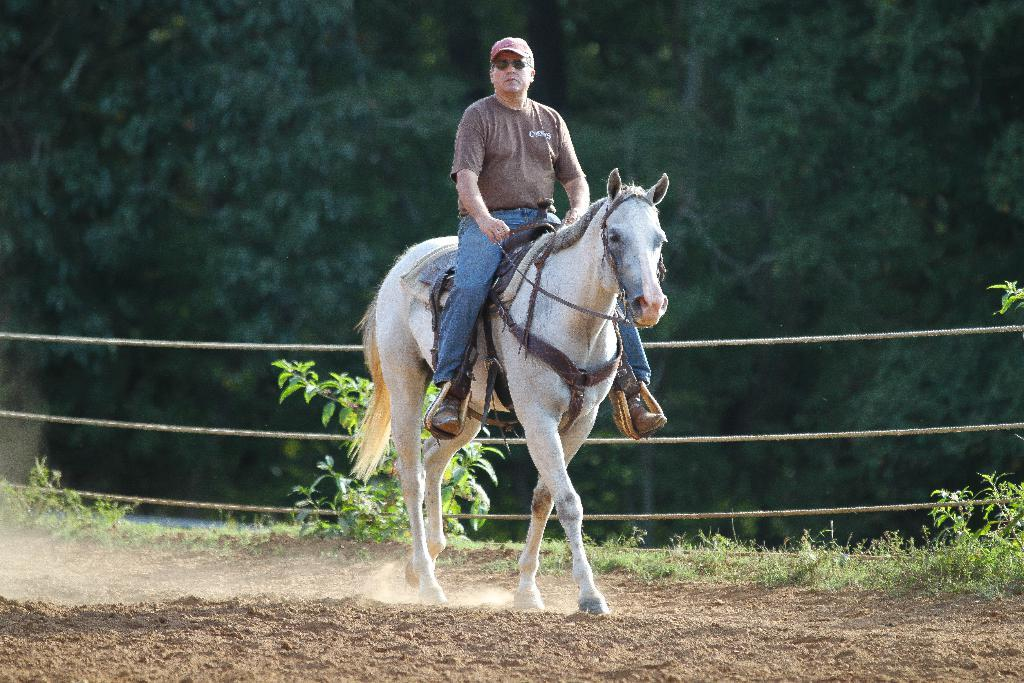What animal is present in the image? There is a horse in the image. What is the horse doing in the image? The horse is walking on the ground. Who is on the horse? There is a man sitting on the horse. Can you describe the man's attire? The man is wearing a cap and goggles. What can be seen in the background of the image? There are ropes and trees visible in the background of the image. What type of root can be seen growing near the seashore in the image? There is no seashore or root present in the image; it features a horse walking with a man on its back, and the background includes ropes and trees. 